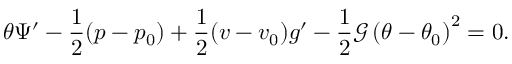Convert formula to latex. <formula><loc_0><loc_0><loc_500><loc_500>\theta \Psi ^ { \prime } - \frac { 1 } { 2 } ( p - p _ { 0 } ) + \frac { 1 } { 2 } ( v - v _ { 0 } ) g ^ { \prime } - \frac { 1 } { 2 } \mathcal { G } \left ( \theta - \theta _ { 0 } \right ) ^ { 2 } = 0 .</formula> 